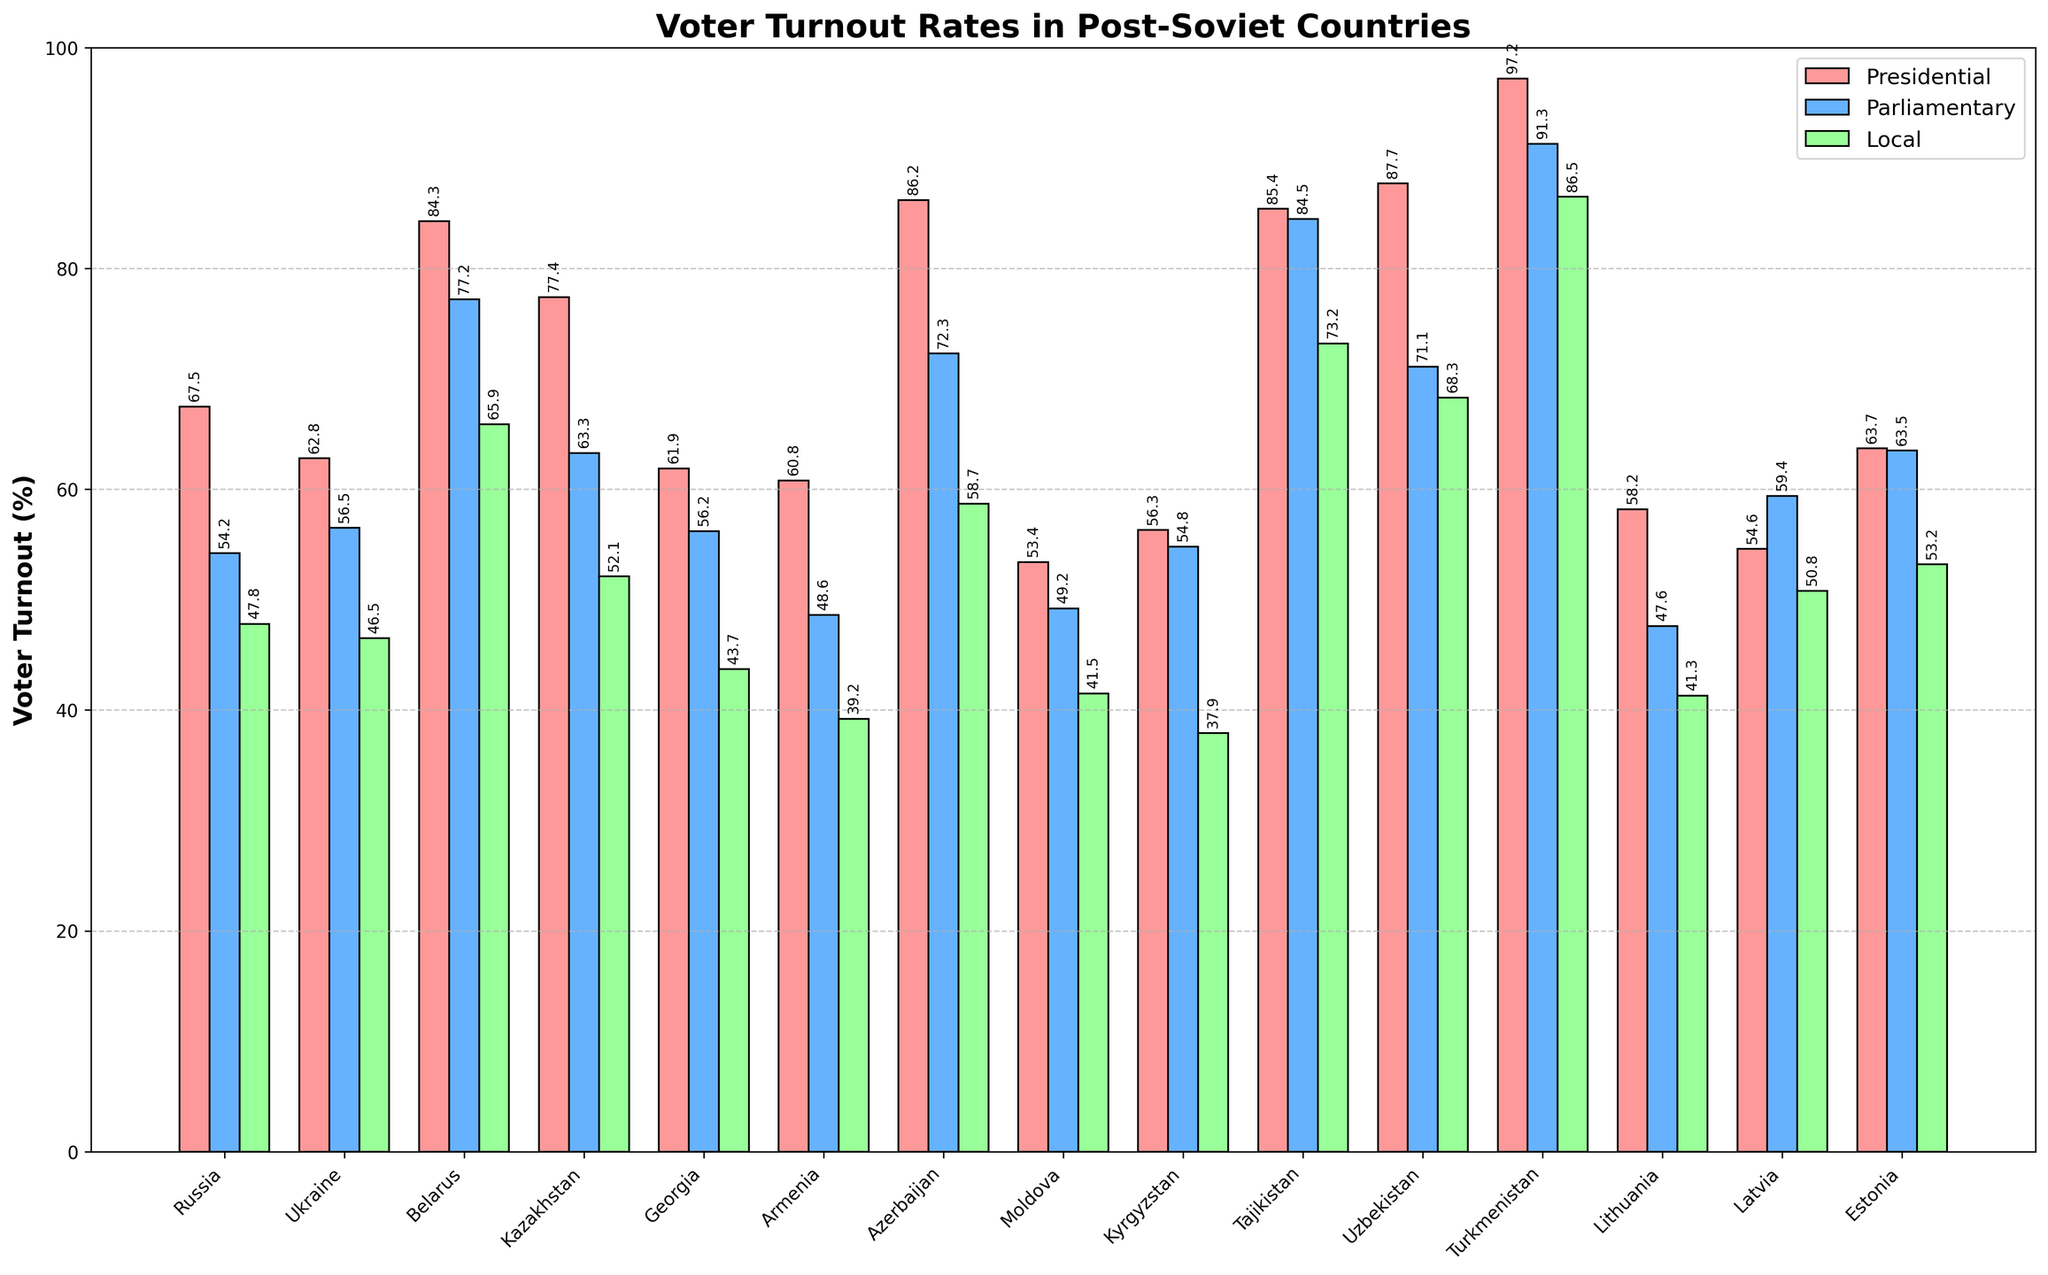Which country has the highest voter turnout in presidential elections? By looking at the height of the bars colored in red for each country, Turkmenistan has the highest bar indicating the highest voter turnout for presidential elections.
Answer: Turkmenistan How much higher is voter turnout for presidential elections compared to local elections in Belarus? The voter turnout for presidential elections in Belarus is 84.3%, and for local elections, it is 65.9%. The difference is calculated as 84.3 - 65.9.
Answer: 18.4% Which country shows the smallest difference between parliamentary and local election turnouts? By examining the heights of the blue and green bars for each country, Estonia shows the smallest difference as the bars are closest in height, with parliamentary at 63.5% and local at 53.2%, resulting in a difference of 10.3%.
Answer: Estonia What is the average voter turnout for parliamentary elections across all the countries? Sum the voter turnout rates for parliamentary elections across all countries and then divide by the number of countries: (54.2 + 56.5 + 77.2 + 63.3 + 56.2 + 48.6 + 72.3 + 49.2 + 54.8 + 84.5 + 71.1 + 91.3 + 47.6 + 59.4 + 63.5) / 15. The calculation yields 66.3%.
Answer: 66.3% What is the median voter turnout for local elections? Rank the voter turnout rates for local elections: 37.9, 39.2, 41.3, 41.5, 43.7, 46.5, 47.8, 50.8, 52.1, 53.2, 58.7, 65.9, 68.3, 73.2, 86.5. The median value is the 8th value in this ordered list.
Answer: 50.8% Which countries have a turnout rate greater than 70% for parliamentary elections? By looking at the heights of the blue bars, identify the countries where the turnout exceeds 70%. These countries are Belarus (77.2%), Azerbaijan (72.3%), Tajikistan (84.5%), and Turkmenistan (91.3%).
Answer: Belarus, Azerbaijan, Tajikistan, Turkmenistan How does voter turnout in local elections in Kazakhstan compare to Armenia? The green bar representing local election turnout in Kazakhstan is 52.1%, whereas for Armenia it is 39.2%. Kazakhstan has a higher turnout for local elections compared to Armenia.
Answer: Kazakhstan has higher turnout What is the total voter turnout for presidential elections in the Baltic States (Latvia, Lithuania, and Estonia)? Add the voter turnout rates for presidential elections in the Baltic States: 54.6% (Latvia) + 58.2% (Lithuania) + 63.7% (Estonia). The total is 176.5%.
Answer: 176.5% Which country shows a greater difference between presidential and parliamentary turnout, Azerbaijan or Uzbekistan? For Azerbaijan, the presidential turnout is 86.2% and parliamentary is 72.3%, resulting in a difference of 13.9%. For Uzbekistan, the presidential turnout is 87.7% and parliamentary is 71.1%, resulting in a difference of 16.6%. Uzbekistan has a greater difference.
Answer: Uzbekistan In which type of election do the majority of countries have the lowest voter turnout? Compare the heights of the red, blue, and green bars for each country. For the majority of countries, the green bars (local elections) are the lowest.
Answer: Local elections 